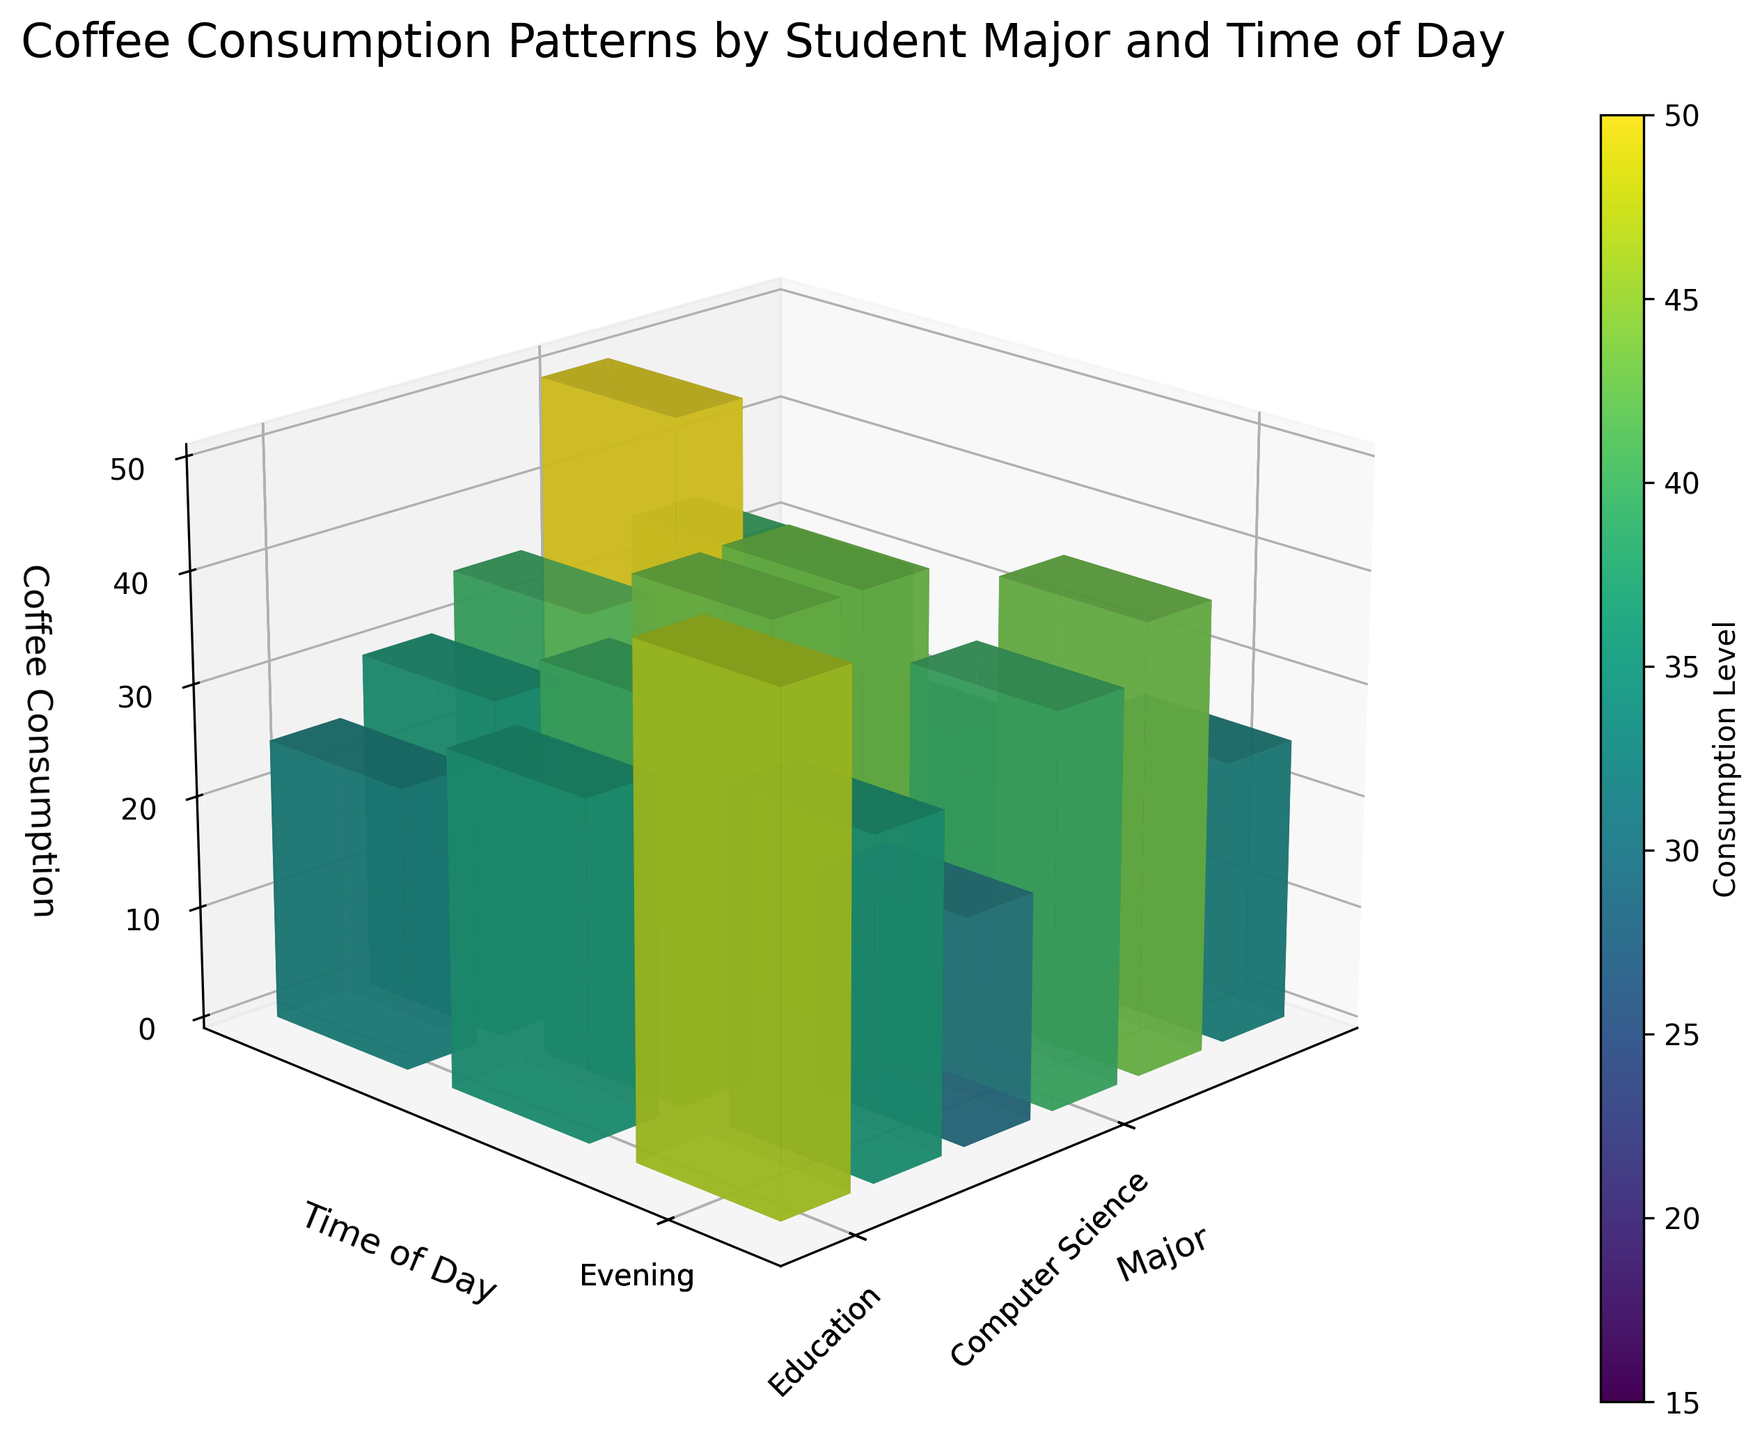What is the major and time of day combination with the highest coffee consumption? The figure shows different coffee consumption levels for each major and time of day. By identifying the highest bar, we can see that Computer Science students in the morning have the highest consumption of 50 units.
Answer: Computer Science, Morning Which major has the lowest afternoon coffee consumption? To find the lowest afternoon consumption, compare the heights of the bars labeled "Afternoon." The lowest afternoon bar is for Sciences, with a consumption of 25 units.
Answer: Sciences How does the coffee consumption of Liberal Arts students compare between morning and evening? Observe the heights of the bars for Liberal Arts during the morning and evening times. The morning consumption is 30 units, while the evening consumption is 40 units. So, evening consumption is higher for Liberal Arts students.
Answer: Evening consumption is higher What is the average coffee consumption for Education students throughout the day? To find the average, sum the coffee consumption values for Education students (25 in the morning, 30 in the afternoon, 35 in the evening) and divide by the number of times of day (3). (25 + 30 + 35) / 3 = 30 units.
Answer: 30 units Which time of day generally has the highest coffee consumption across all majors? Compare the overall heights of the bars for morning, afternoon, and evening across all majors. Morning consumption has the most consistently high bars compared to afternoon and evening.
Answer: Morning What is the difference in coffee consumption between Engineering and Business students in the morning? Check the morning consumption bars for Engineering (45 units) and Business (35 units), then compute the difference. 45 - 35 = 10 units.
Answer: 10 units What is the total coffee consumption for Computer Science students throughout the day? Sum the consumption values for Computer Science students in the morning (50 units), afternoon (35 units), and evening (30 units). 50 + 35 + 30 = 115 units.
Answer: 115 units Which major has the most significant increase in coffee consumption from morning to evening? Calculate the difference in consumption from morning to evening for each major. Engineering: 20 - 45 = -25, Business: 25 - 35 = -10, Liberal Arts: 40 - 30 = 10, Sciences: 15 - 40 = -25, Education: 35 - 25 = 10, Computer Science: 30 - 50 = -20. Liberal Arts and Education have the same increase of 10 units, which is the highest positive increase.
Answer: Liberal Arts and Education 